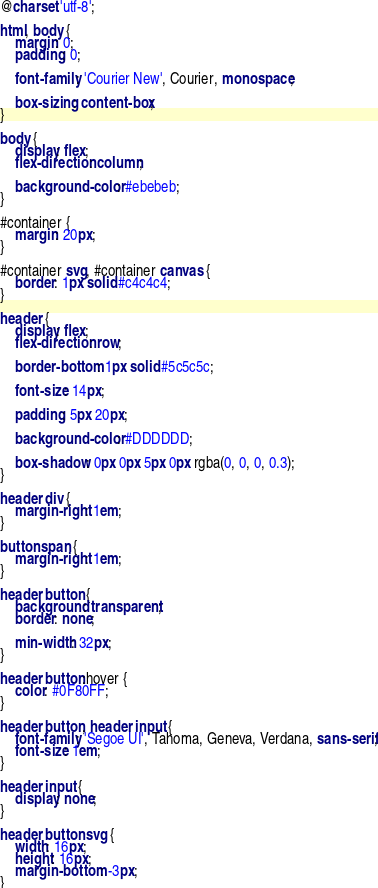<code> <loc_0><loc_0><loc_500><loc_500><_CSS_>@charset 'utf-8';

html, body {
    margin: 0;
    padding: 0;

    font-family: 'Courier New', Courier, monospace;

    box-sizing: content-box;
}

body {
    display: flex;
    flex-direction: column;

    background-color: #ebebeb;
}

#container {
    margin: 20px;
}

#container svg, #container canvas {
    border: 1px solid #c4c4c4;
}

header {
    display: flex;
    flex-direction: row;

    border-bottom: 1px solid #5c5c5c;

    font-size: 14px;

    padding: 5px 20px;

    background-color: #DDDDDD;

    box-shadow: 0px 0px 5px 0px rgba(0, 0, 0, 0.3);
}

header div {
    margin-right: 1em;
}

button span {
    margin-right: 1em;
}

header button {
    background: transparent;
    border: none;

    min-width: 32px;
}

header button:hover {
    color: #0F80FF;
}

header button, header input {
    font-family: 'Segoe UI', Tahoma, Geneva, Verdana, sans-serif;
    font-size: 1em;
}

header input {
    display: none;
}

header button svg {
    width: 16px;
    height: 16px;
    margin-bottom: -3px;
}</code> 